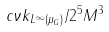Convert formula to latex. <formula><loc_0><loc_0><loc_500><loc_500>c \nu \| k \| _ { L ^ { \infty } ( \mu _ { G } ) } / 2 ^ { 5 } M ^ { 3 }</formula> 